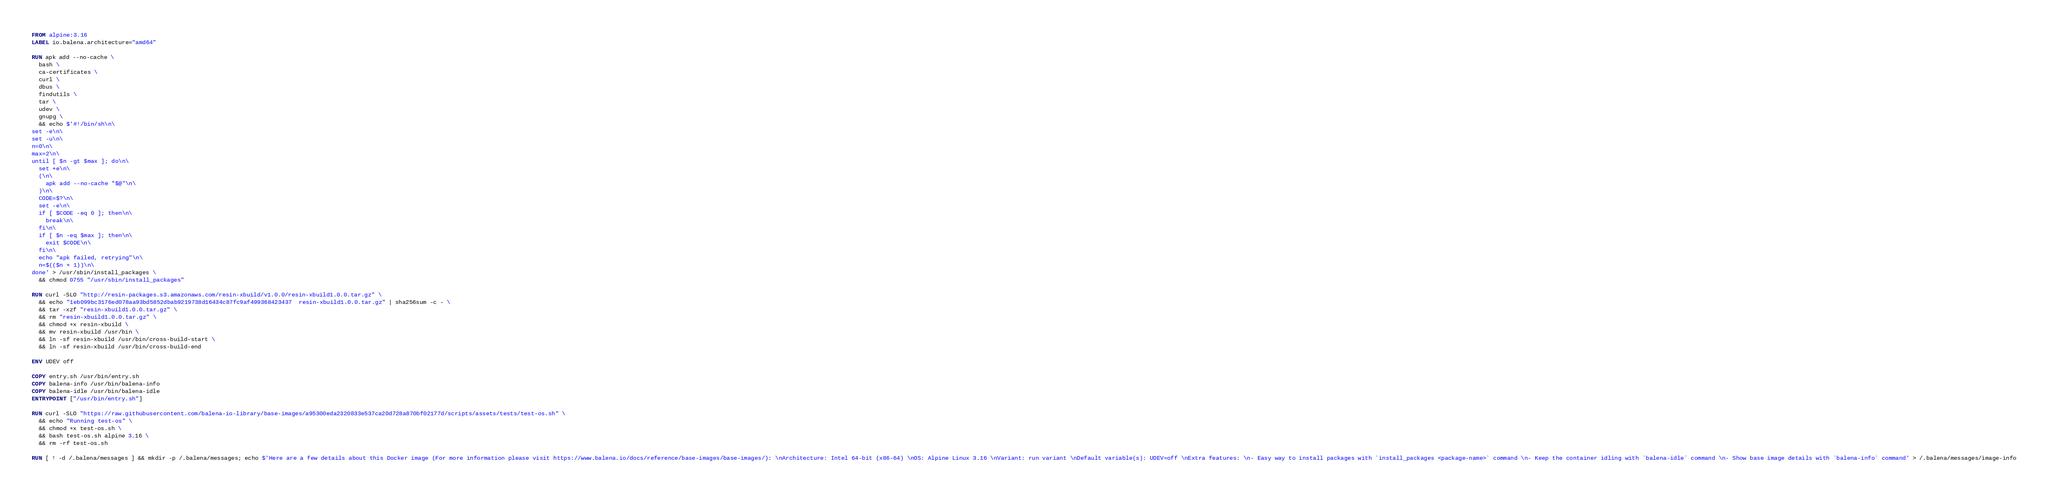<code> <loc_0><loc_0><loc_500><loc_500><_Dockerfile_>FROM alpine:3.16
LABEL io.balena.architecture="amd64"

RUN apk add --no-cache \
  bash \
  ca-certificates \
  curl \
  dbus \
  findutils \
  tar \
  udev \
  gnupg \
  && echo $'#!/bin/sh\n\
set -e\n\
set -u\n\
n=0\n\
max=2\n\
until [ $n -gt $max ]; do\n\
  set +e\n\
  (\n\
    apk add --no-cache "$@"\n\
  )\n\
  CODE=$?\n\
  set -e\n\
  if [ $CODE -eq 0 ]; then\n\
    break\n\
  fi\n\
  if [ $n -eq $max ]; then\n\
    exit $CODE\n\
  fi\n\
  echo "apk failed, retrying"\n\
  n=$(($n + 1))\n\
done' > /usr/sbin/install_packages \
  && chmod 0755 "/usr/sbin/install_packages"

RUN curl -SLO "http://resin-packages.s3.amazonaws.com/resin-xbuild/v1.0.0/resin-xbuild1.0.0.tar.gz" \
  && echo "1eb099bc3176ed078aa93bd5852dbab9219738d16434c87fc9af499368423437  resin-xbuild1.0.0.tar.gz" | sha256sum -c - \
  && tar -xzf "resin-xbuild1.0.0.tar.gz" \
  && rm "resin-xbuild1.0.0.tar.gz" \
  && chmod +x resin-xbuild \
  && mv resin-xbuild /usr/bin \
  && ln -sf resin-xbuild /usr/bin/cross-build-start \
  && ln -sf resin-xbuild /usr/bin/cross-build-end

ENV UDEV off

COPY entry.sh /usr/bin/entry.sh
COPY balena-info /usr/bin/balena-info
COPY balena-idle /usr/bin/balena-idle
ENTRYPOINT ["/usr/bin/entry.sh"]

RUN curl -SLO "https://raw.githubusercontent.com/balena-io-library/base-images/a95300eda2320833e537ca20d728a870bf02177d/scripts/assets/tests/test-os.sh" \
  && echo "Running test-os" \
  && chmod +x test-os.sh \
  && bash test-os.sh alpine 3.16 \
  && rm -rf test-os.sh

RUN [ ! -d /.balena/messages ] && mkdir -p /.balena/messages; echo $'Here are a few details about this Docker image (For more information please visit https://www.balena.io/docs/reference/base-images/base-images/): \nArchitecture: Intel 64-bit (x86-64) \nOS: Alpine Linux 3.16 \nVariant: run variant \nDefault variable(s): UDEV=off \nExtra features: \n- Easy way to install packages with `install_packages <package-name>` command \n- Keep the container idling with `balena-idle` command \n- Show base image details with `balena-info` command' > /.balena/messages/image-info</code> 